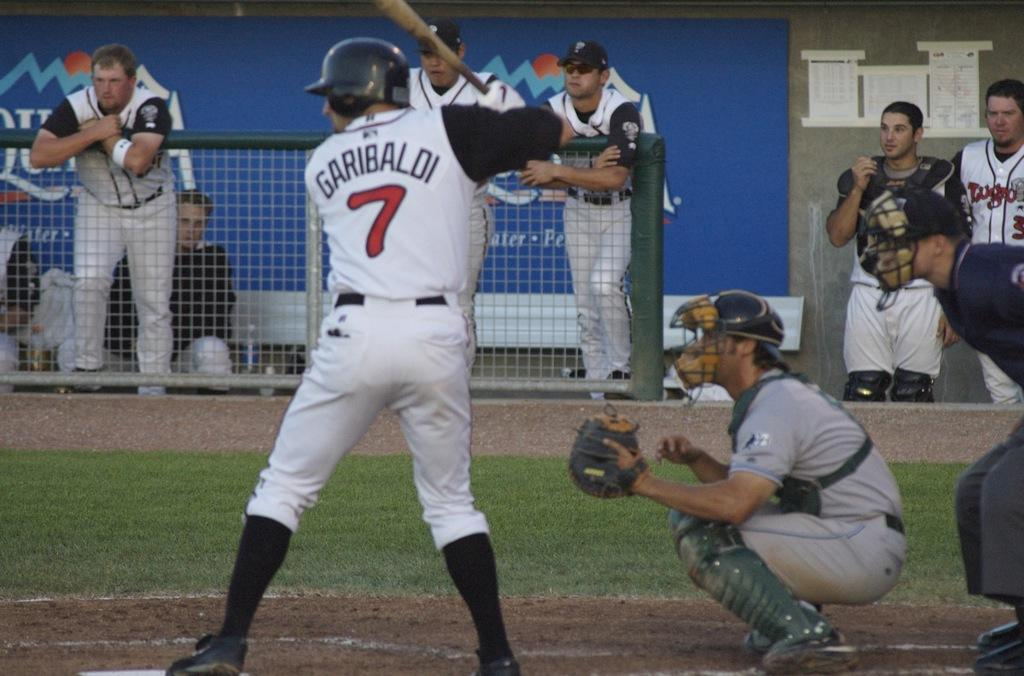<image>
Give a short and clear explanation of the subsequent image. a player playing baseball with the number 7 